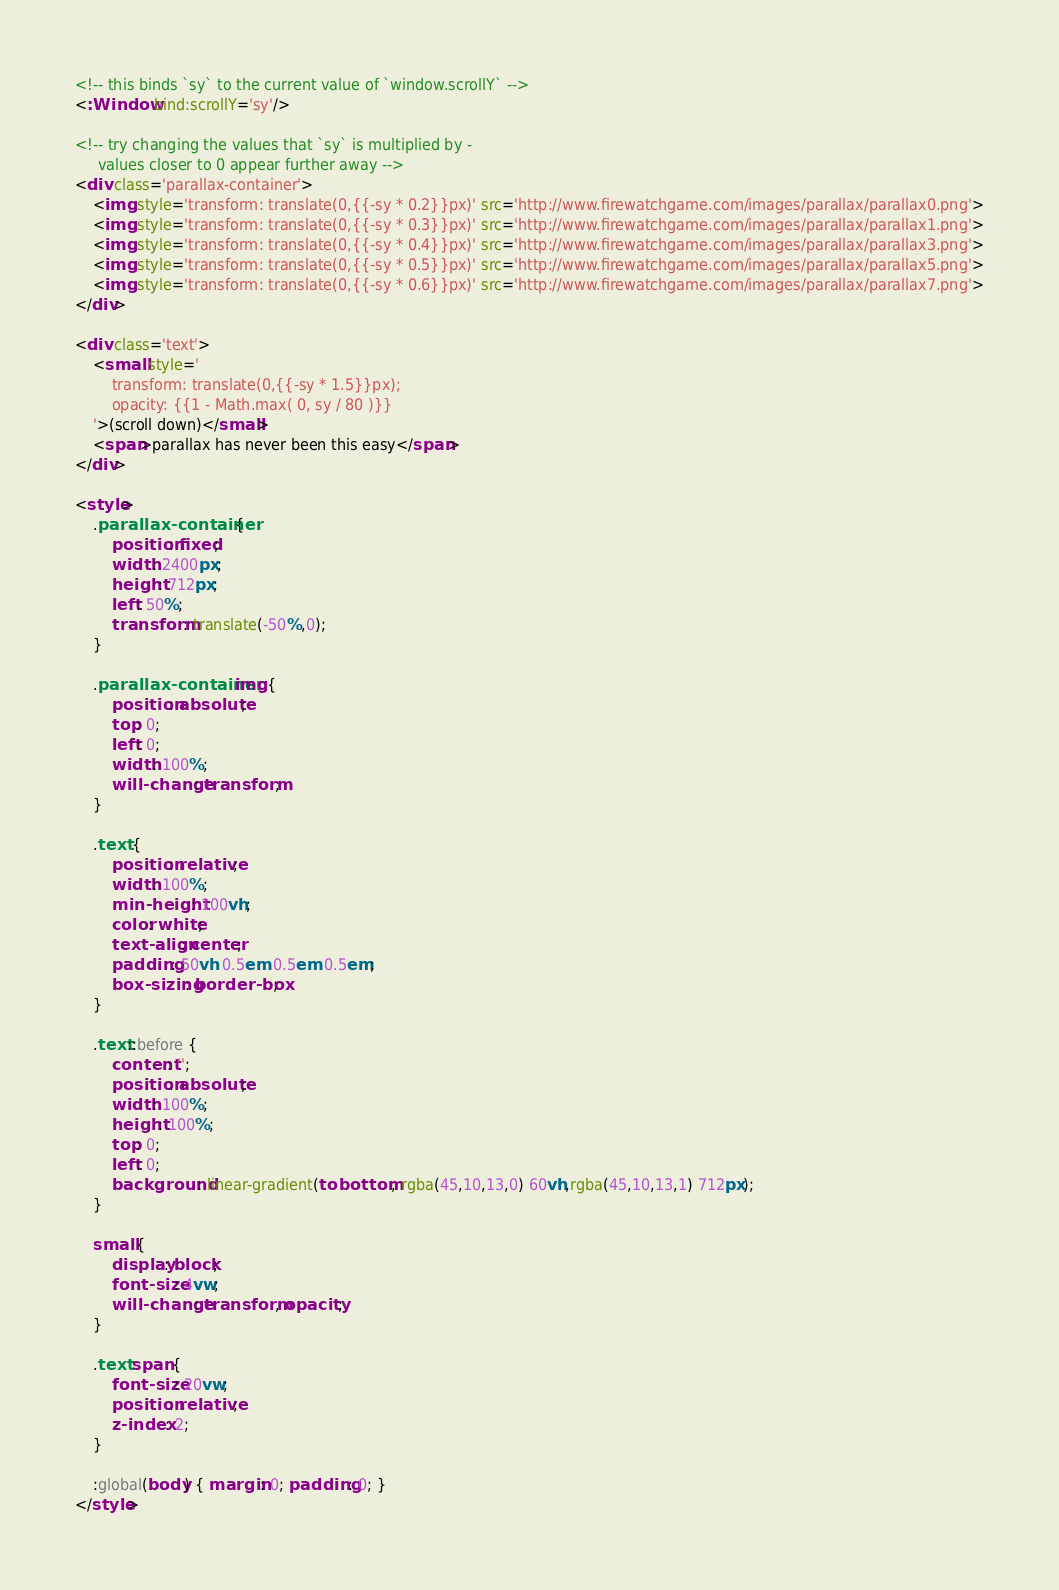Convert code to text. <code><loc_0><loc_0><loc_500><loc_500><_HTML_><!-- this binds `sy` to the current value of `window.scrollY` -->
<:Window bind:scrollY='sy'/>

<!-- try changing the values that `sy` is multiplied by -
     values closer to 0 appear further away -->
<div class='parallax-container'>
	<img style='transform: translate(0,{{-sy * 0.2}}px)' src='http://www.firewatchgame.com/images/parallax/parallax0.png'>
	<img style='transform: translate(0,{{-sy * 0.3}}px)' src='http://www.firewatchgame.com/images/parallax/parallax1.png'>
	<img style='transform: translate(0,{{-sy * 0.4}}px)' src='http://www.firewatchgame.com/images/parallax/parallax3.png'>
	<img style='transform: translate(0,{{-sy * 0.5}}px)' src='http://www.firewatchgame.com/images/parallax/parallax5.png'>
	<img style='transform: translate(0,{{-sy * 0.6}}px)' src='http://www.firewatchgame.com/images/parallax/parallax7.png'>
</div>

<div class='text'>
	<small style='
		transform: translate(0,{{-sy * 1.5}}px);
		opacity: {{1 - Math.max( 0, sy / 80 )}}
	'>(scroll down)</small>
	<span>parallax has never been this easy</span>
</div>

<style>
	.parallax-container {
		position: fixed;
		width: 2400px;
		height: 712px;
		left: 50%;
		transform: translate(-50%,0);
	}

	.parallax-container img {
		position: absolute;
		top: 0;
		left: 0;
		width: 100%;
		will-change: transform;
	}

	.text {
		position: relative;
		width: 100%;
		min-height: 100vh;
		color: white;
		text-align: center;
		padding: 50vh 0.5em 0.5em 0.5em;
		box-sizing: border-box;
	}

	.text::before {
		content: '';
		position: absolute;
		width: 100%;
		height: 100%;
		top: 0;
		left: 0;
		background: linear-gradient(to bottom, rgba(45,10,13,0) 60vh,rgba(45,10,13,1) 712px);
	}

	small {
		display: block;
		font-size: 4vw;
		will-change: transform, opacity;
	}

	.text span {
		font-size: 20vw;
		position: relative;
		z-index: 2;
	}

	:global(body) { margin: 0; padding: 0; }
</style></code> 